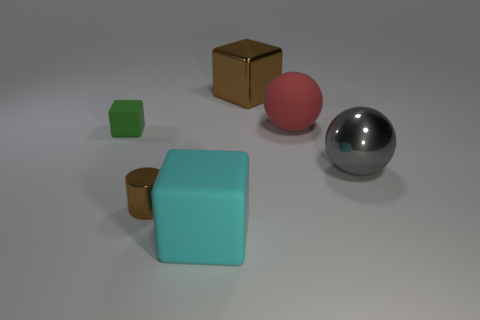There is a big rubber object behind the tiny metallic thing; what color is it?
Provide a short and direct response. Red. The brown cylinder that is the same material as the gray thing is what size?
Offer a very short reply. Small. What number of other large gray objects are the same shape as the gray thing?
Your response must be concise. 0. What is the material of the red object that is the same size as the cyan thing?
Your answer should be compact. Rubber. Are there any tiny red cylinders that have the same material as the large brown block?
Ensure brevity in your answer.  No. What is the color of the rubber object that is both behind the tiny brown object and right of the cylinder?
Provide a short and direct response. Red. How many other objects are the same color as the tiny cylinder?
Offer a very short reply. 1. What material is the big block left of the brown object right of the large rubber thing in front of the tiny brown shiny cylinder?
Make the answer very short. Rubber. How many balls are either green matte objects or cyan objects?
Keep it short and to the point. 0. Are there any other things that are the same size as the gray sphere?
Your answer should be compact. Yes. 